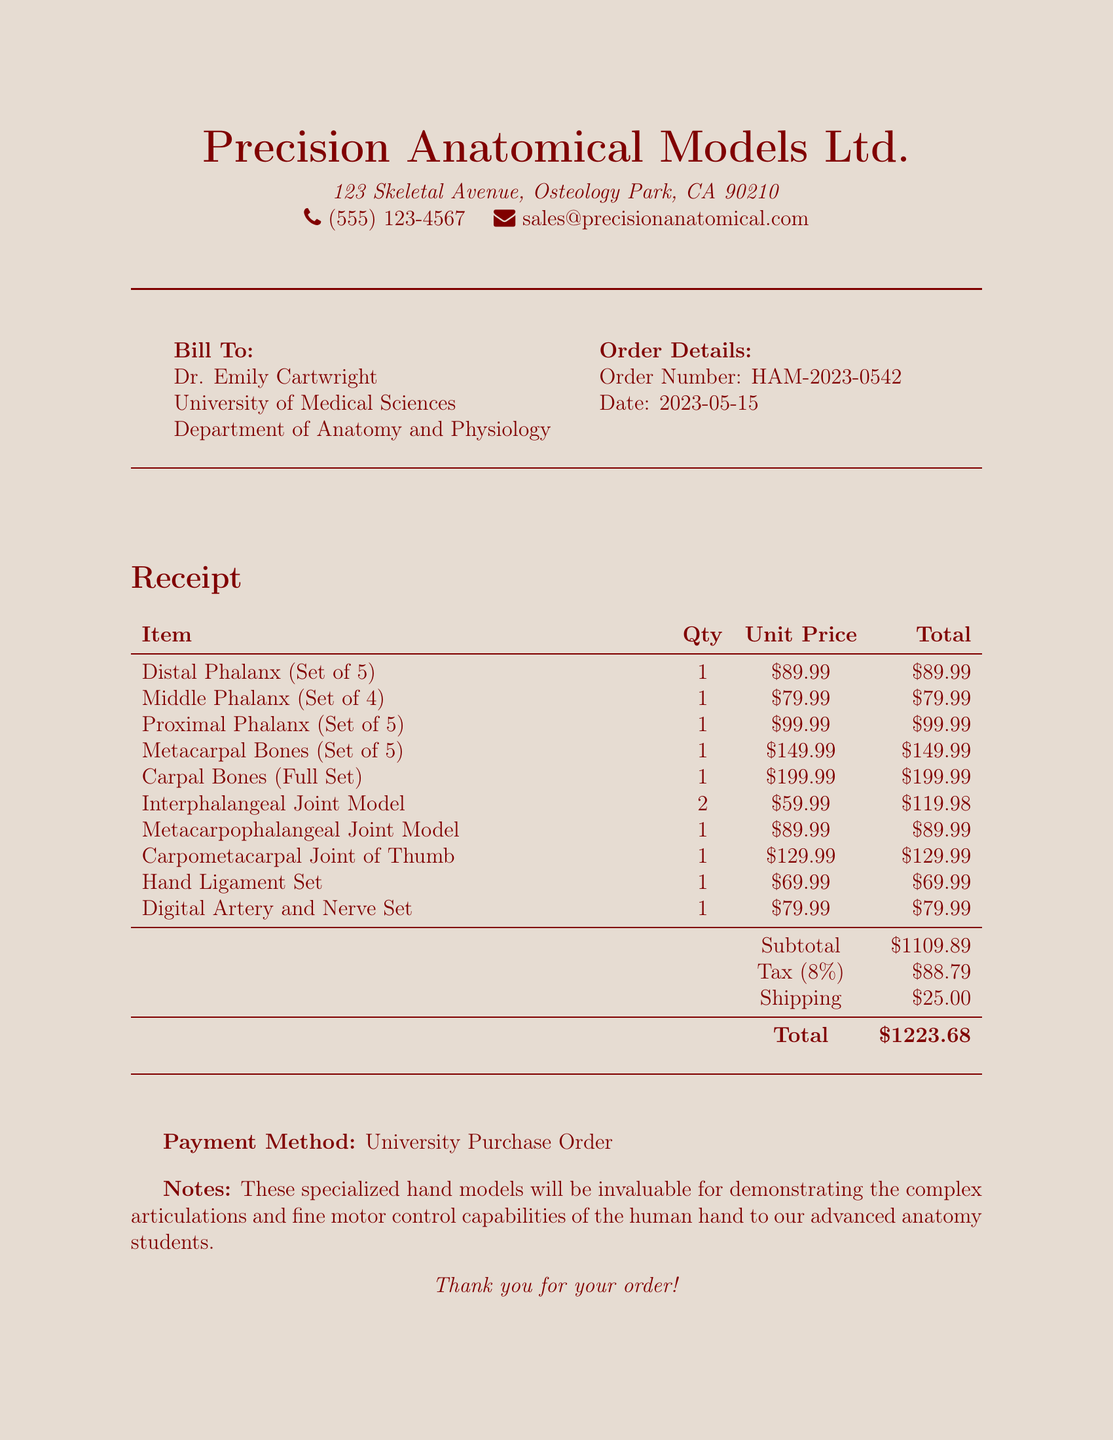what is the order number? The order number is provided in the document as a specific identifier for tracking purposes.
Answer: HAM-2023-0542 who is the customer? The customer’s name is mentioned clearly in the document as the individual placing the order.
Answer: Dr. Emily Cartwright what is the tax amount? The tax amount is specified in the document, detailing the additional charges applicable to the subtotal.
Answer: $88.79 how many Interphalangeal Joint Models were ordered? The document specifies the quantity ordered for each item, which includes the Interphalangeal Joint Models.
Answer: 2 what is the total cost of the order? The total cost is derived from the subtotal, tax, and shipping, clearly stated in the receipt.
Answer: $1223.68 which payment method was used? The payment method indicates how the transaction was settled, which is explicitly noted at the end of the document.
Answer: University Purchase Order what does the note mention about the hand models? The note provides insight into the significance of the purchased items, indicating their importance for educational purposes.
Answer: Invaluable for demonstrating the complex articulations and fine motor control capabilities how many carpal bones are in the full set? The document describes the complete set of carpal bones and provides a count of how many are included.
Answer: 8 what is the shipping cost? The shipping cost is listed as a separate line item in the document for clarity in pricing.
Answer: $25.00 